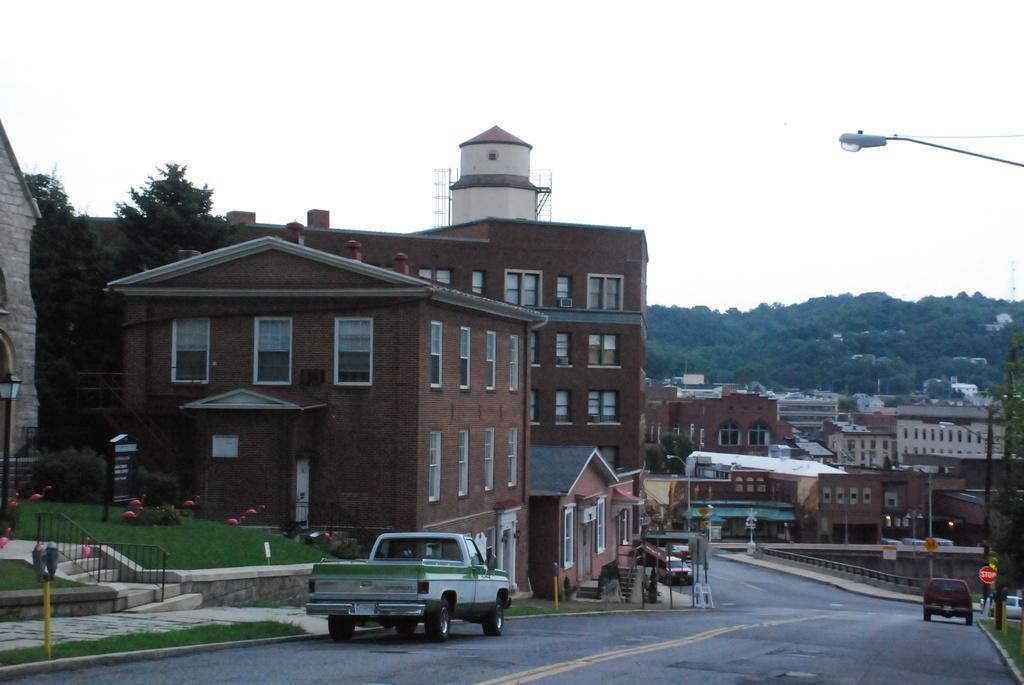Please provide a concise description of this image. At the bottom of the image there is a road with few vehicles. Beside the road on the left side there is a footpath with poles and name boards and also there are buildings with brick walls, windows and roofs. In the background there are buildings, poles with street lights and sign boards. And also there are trees in the background. At the top of the image there is a sky. 